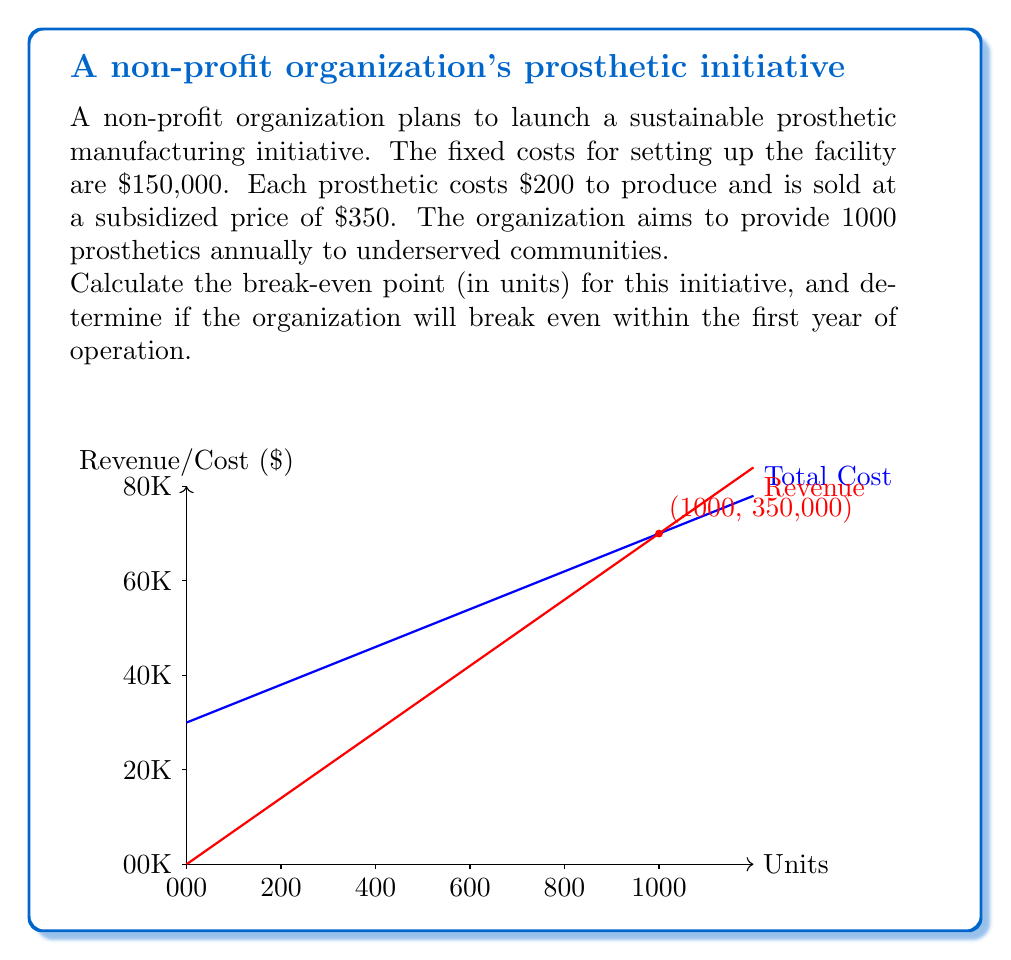Teach me how to tackle this problem. To calculate the break-even point, we need to determine the number of units at which total revenue equals total cost. Let's follow these steps:

1) Define variables:
   Let $x$ be the number of units (prosthetics)
   Fixed costs (FC) = $150,000
   Variable cost per unit (VC) = $200
   Price per unit (P) = $350

2) Set up the break-even equation:
   Total Revenue = Total Cost
   $Px = FC + VCx$

3) Substitute the values:
   $350x = 150,000 + 200x$

4) Solve for $x$:
   $350x - 200x = 150,000$
   $150x = 150,000$
   $x = 1,000$

5) Check if the organization will break even within the first year:
   The organization aims to provide 1,000 prosthetics annually.
   The break-even point is exactly 1,000 units.

Therefore, the organization will break even at the end of the first year if they meet their goal of 1,000 units.

To verify:
At 1,000 units:
Revenue = $350 * 1,000 = $350,000
Total Cost = $150,000 + ($200 * 1,000) = $350,000

Revenue equals Total Cost, confirming the break-even point.
Answer: 1,000 units; Yes, breaks even at year-end if goal met. 